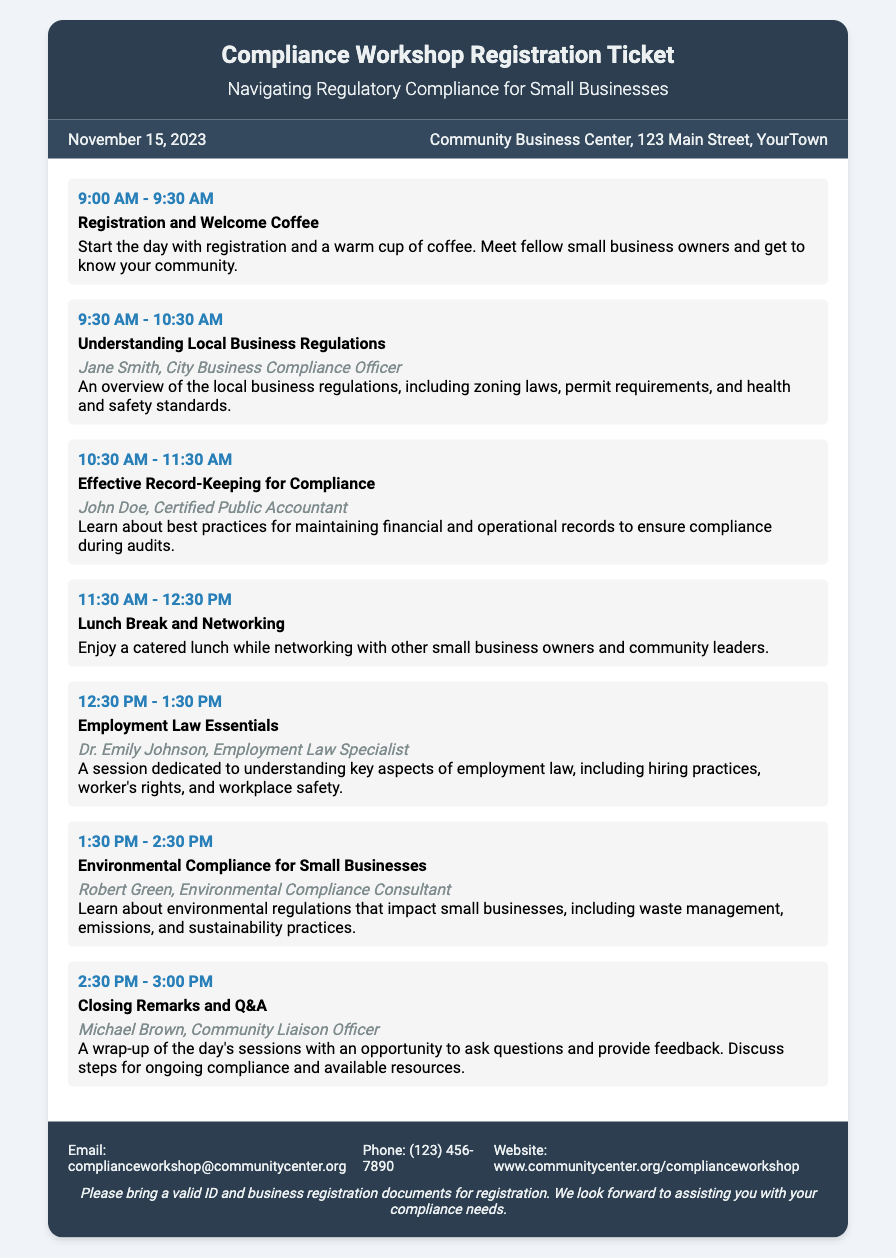What is the date of the workshop? The date of the workshop is specified in the document, which is November 15, 2023.
Answer: November 15, 2023 Where is the workshop taking place? The location of the workshop is mentioned in the document as the Community Business Center, 123 Main Street, YourTown.
Answer: Community Business Center, 123 Main Street, YourTown Who is the speaker for the session on Employment Law Essentials? The document lists Dr. Emily Johnson as the speaker for the Employment Law Essentials session.
Answer: Dr. Emily Johnson What time does the session on Effective Record-Keeping for Compliance start? The start time for the Effective Record-Keeping for Compliance session is mentioned as 10:30 AM.
Answer: 10:30 AM How long is the lunch break? The document indicates that the lunch break lasts for one hour, from 11:30 AM to 12:30 PM.
Answer: One hour What is the title of the closing session? The closing session is titled "Closing Remarks and Q&A," as stated in the schedule.
Answer: Closing Remarks and Q&A What type of food is provided during the lunch break? The document mentions that a catered lunch is provided during the lunch break.
Answer: Catered lunch What is required for registration at the workshop? The document specifies that participants need to bring a valid ID and business registration documents for registration.
Answer: Valid ID and business registration documents 